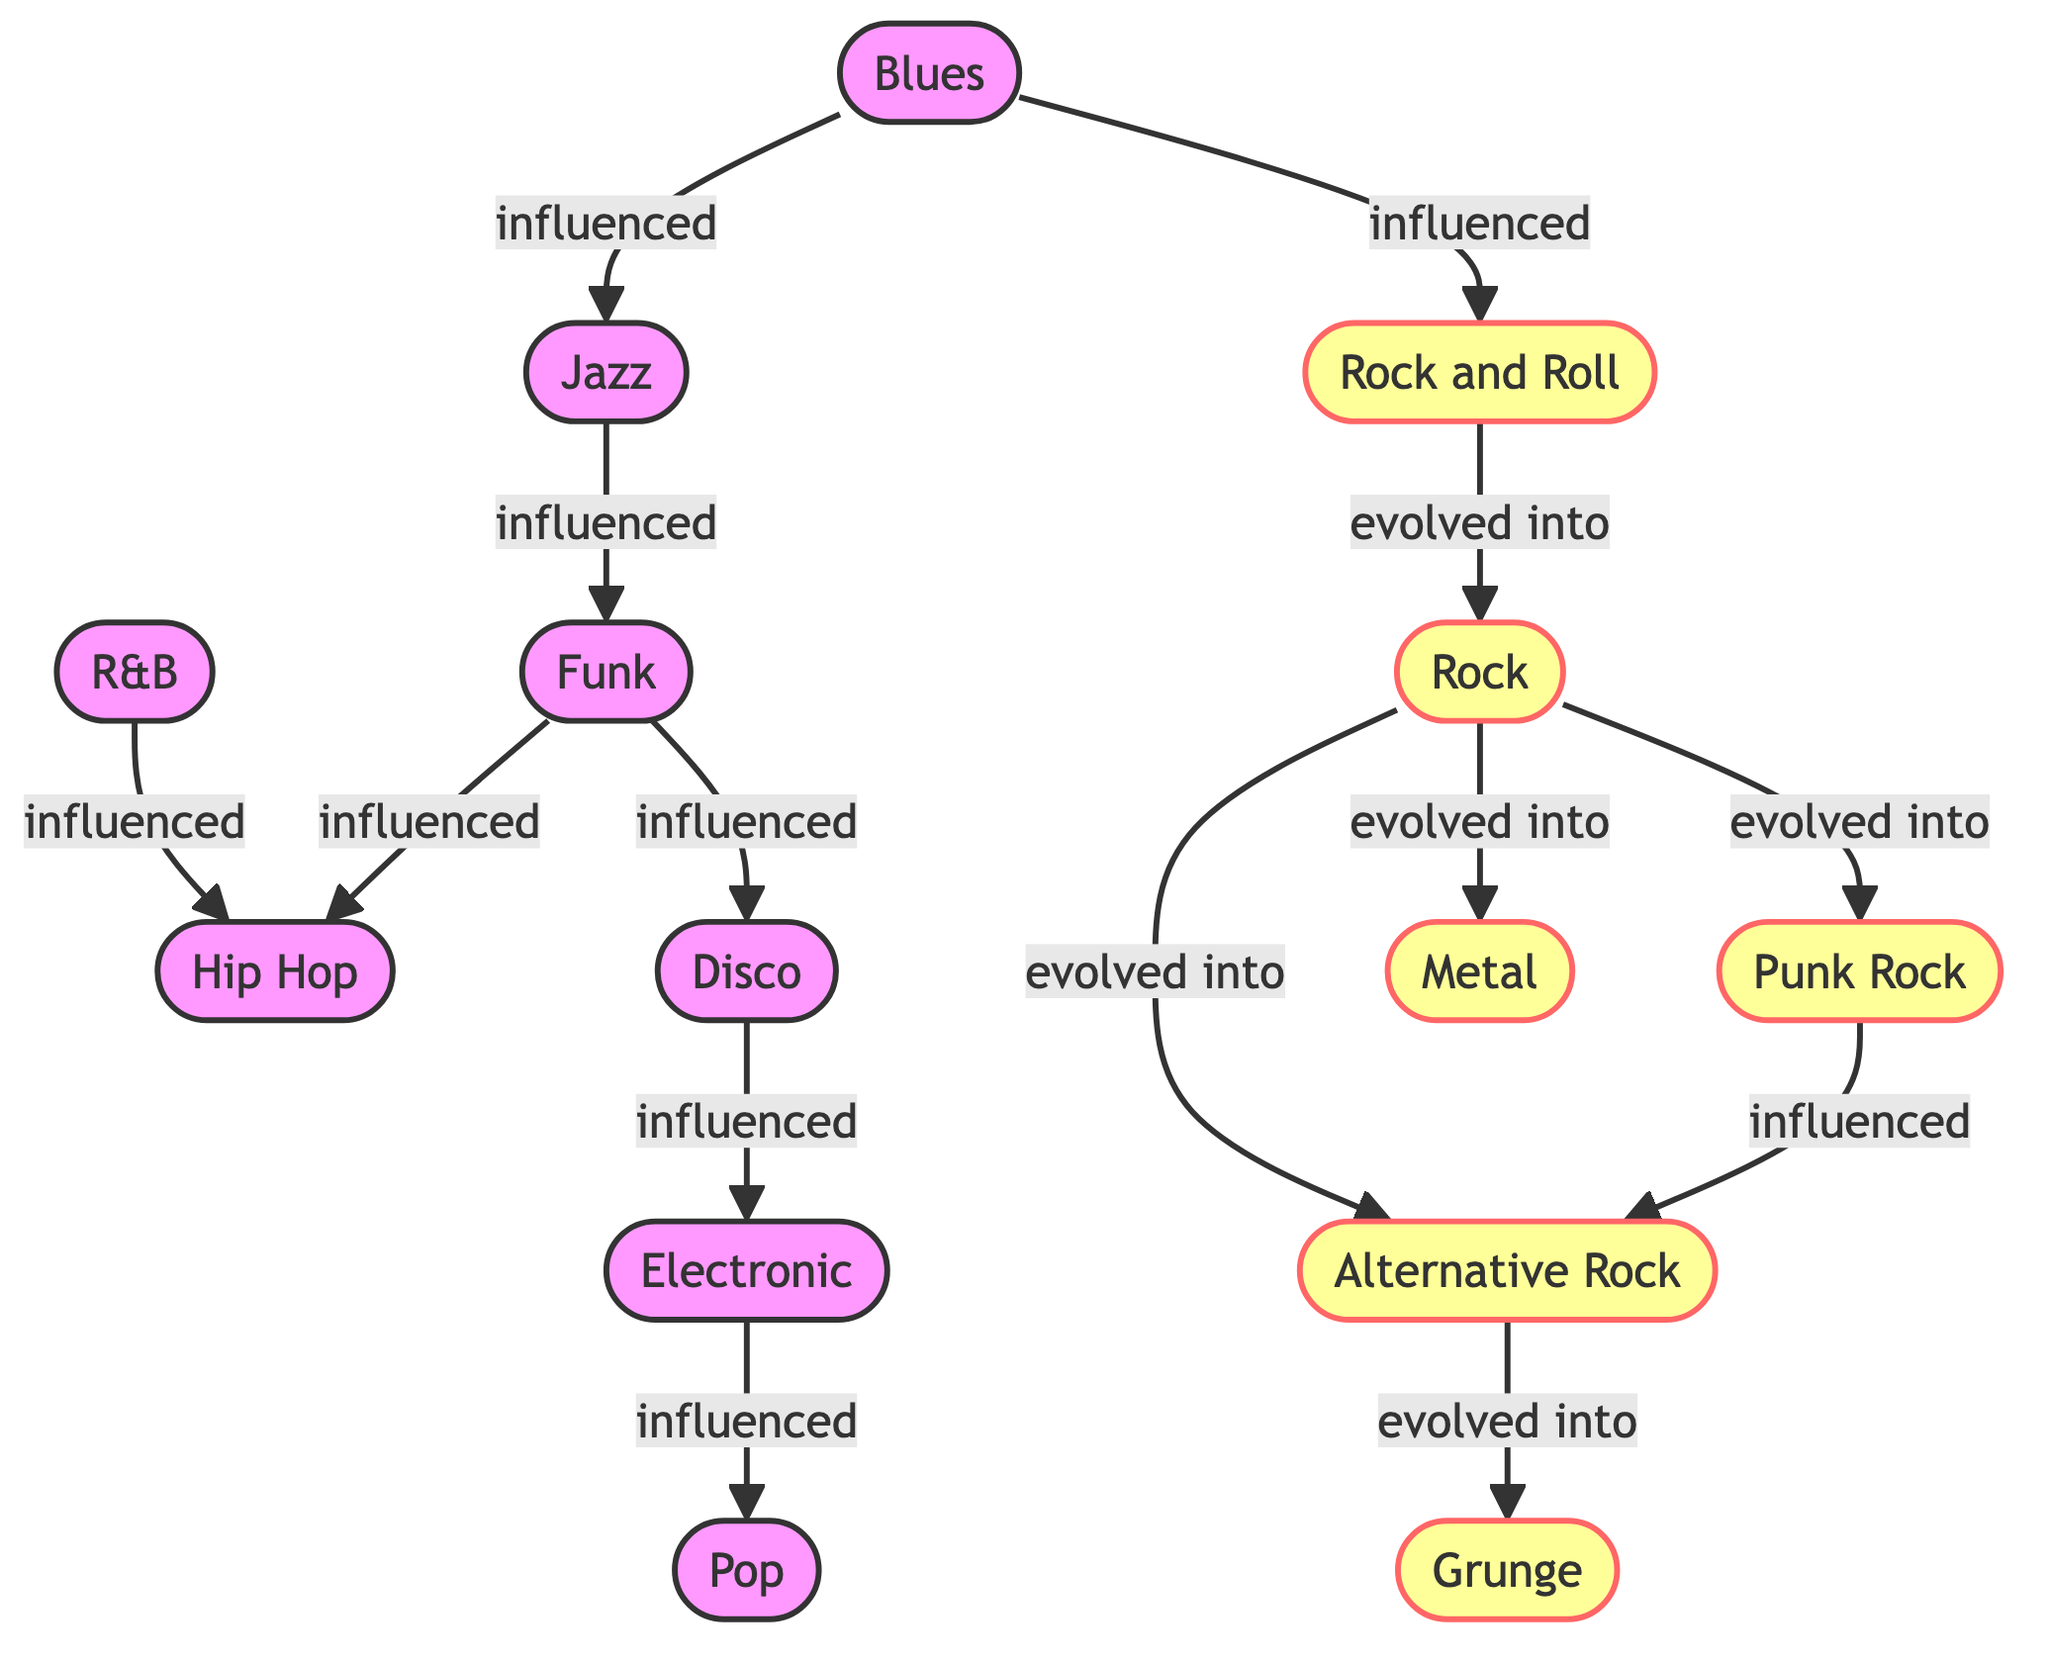What's the total number of music genres represented in the diagram? The diagram lists 14 distinct music genres as nodes. Counting them includes Blues, Jazz, Rock and Roll, Rock, R&B, Hip Hop, Pop, Funk, Disco, Punk Rock, Electronic, Alternative Rock, Grunge, and Metal. Thus, the total count is 14.
Answer: 14 Which genre influenced Hip Hop? According to the directed edges, both R&B and Funk have an influence on Hip Hop. Therefore, Funk and R&B are the genres that influenced Hip Hop.
Answer: R&B and Funk How many genres evolved from Rock? The diagram shows that Rock evolved into three distinct genres: Punk Rock, Metal, and Alternative Rock. Counting these, we find the total is three genres.
Answer: 3 What is the relationship between Blues and Jazz? The directed edge shows that Blues influenced Jazz, which indicates a foundational connection where Blues contributed to the development of Jazz.
Answer: influenced Which genre evolved into Grunge? The diagram specifies that Alternative Rock evolved into Grunge, indicating a direct transformation from one genre to another.
Answer: Alternative Rock What music genre is directly influenced by Disco? Disco influences Electronic. This is a direct relationship indicated by the edge leading from Disco to Electronic in the diagram.
Answer: Electronic Is there a genre that evolved into both Punk Rock and Metal? Yes, the diagram shows that Rock evolved into both Punk Rock and Metal, indicating a branching evolution from the Rock genre.
Answer: Rock Which genre has the most influences? Rock influences three genres, namely Punk Rock, Metal, and Alternative Rock. Therefore, Rock has the most subsequent influences originating from it within the diagram.
Answer: Rock 